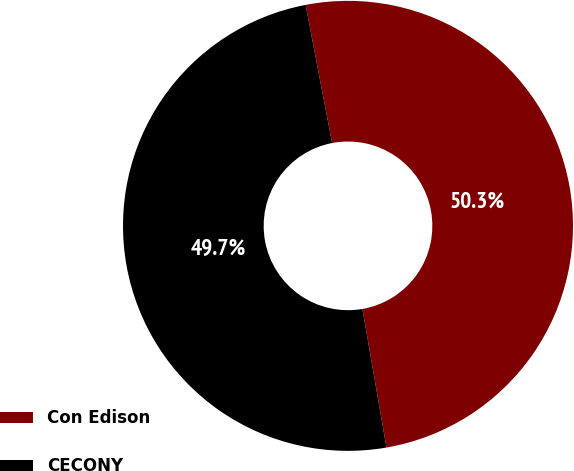<chart> <loc_0><loc_0><loc_500><loc_500><pie_chart><fcel>Con Edison<fcel>CECONY<nl><fcel>50.28%<fcel>49.72%<nl></chart> 